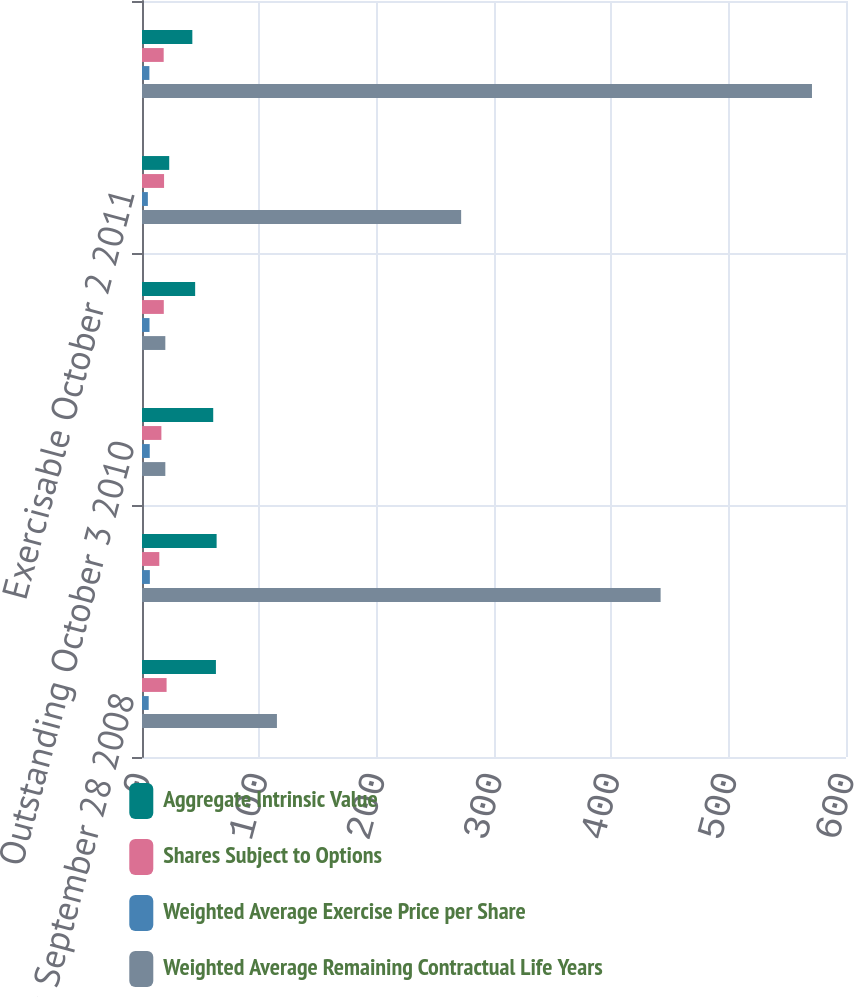<chart> <loc_0><loc_0><loc_500><loc_500><stacked_bar_chart><ecel><fcel>Outstanding September 28 2008<fcel>Outstanding September 27 2009<fcel>Outstanding October 3 2010<fcel>Outstanding October 2 2011<fcel>Exercisable October 2 2011<fcel>Vested and expected to vest<nl><fcel>Aggregate Intrinsic Value<fcel>63<fcel>63.6<fcel>60.7<fcel>45.3<fcel>23.2<fcel>42.9<nl><fcel>Shares Subject to Options<fcel>20.96<fcel>14.75<fcel>16.52<fcel>18.57<fcel>18.81<fcel>18.48<nl><fcel>Weighted Average Exercise Price per Share<fcel>5.7<fcel>6.7<fcel>6.6<fcel>6.4<fcel>5<fcel>6.3<nl><fcel>Weighted Average Remaining Contractual Life Years<fcel>115<fcel>442<fcel>19.885<fcel>19.885<fcel>272<fcel>571<nl></chart> 